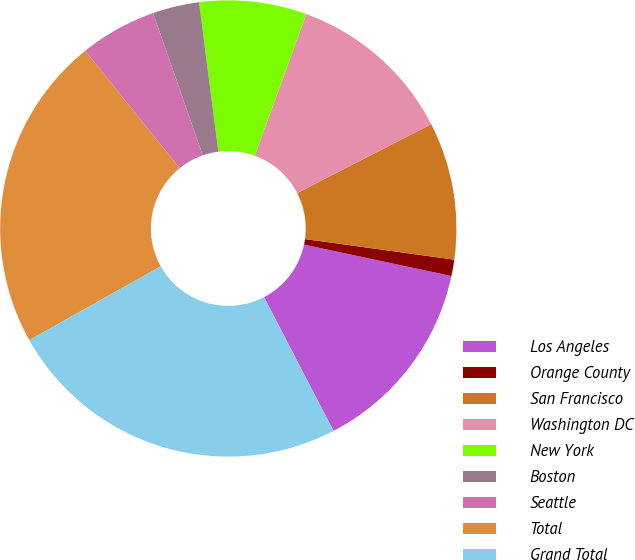Convert chart. <chart><loc_0><loc_0><loc_500><loc_500><pie_chart><fcel>Los Angeles<fcel>Orange County<fcel>San Francisco<fcel>Washington DC<fcel>New York<fcel>Boston<fcel>Seattle<fcel>Total<fcel>Grand Total<nl><fcel>14.03%<fcel>1.16%<fcel>9.74%<fcel>11.89%<fcel>7.6%<fcel>3.3%<fcel>5.45%<fcel>22.34%<fcel>24.49%<nl></chart> 